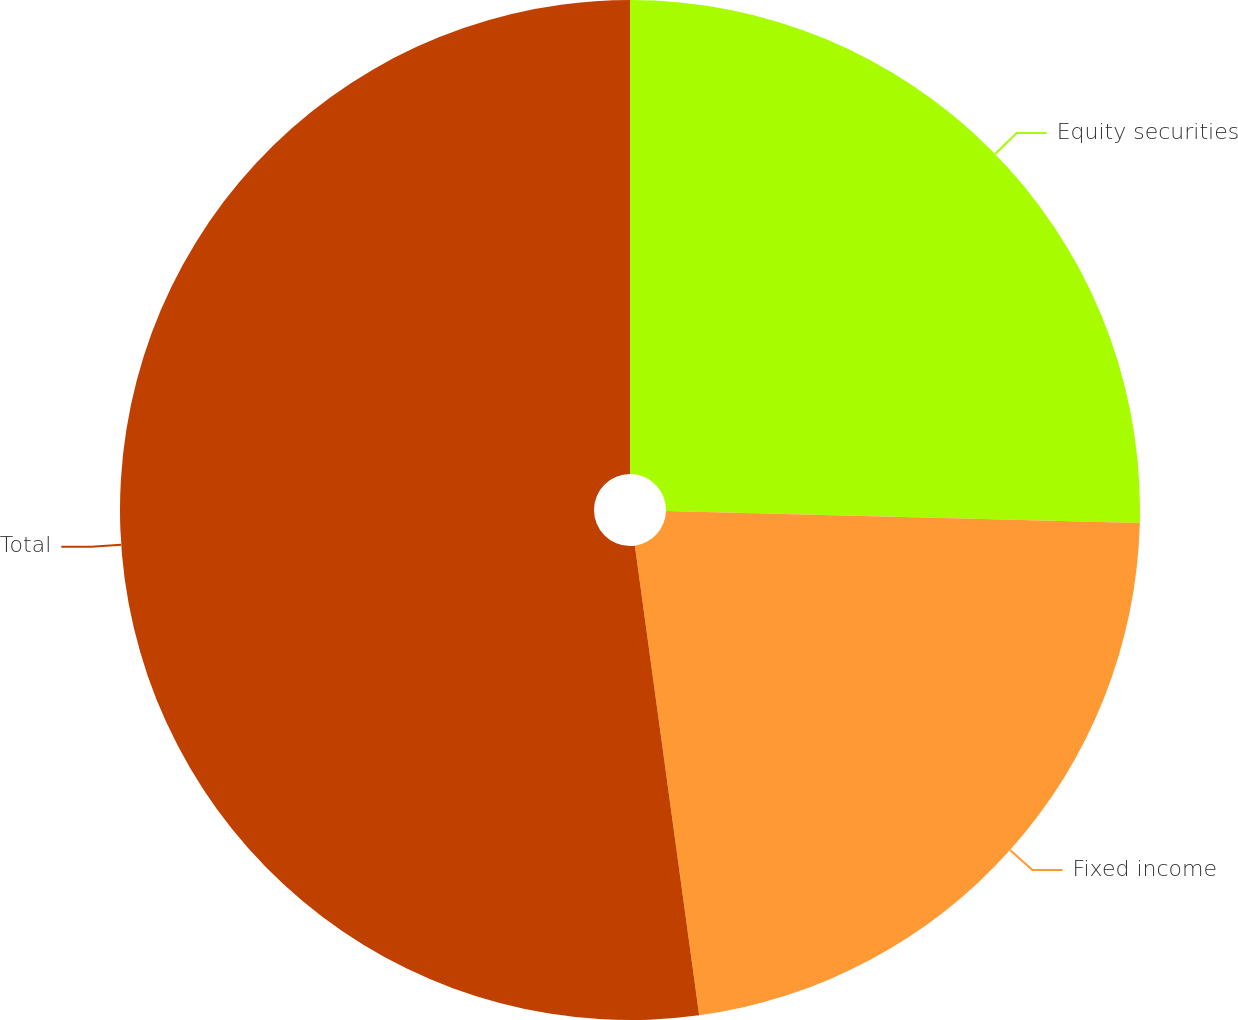Convert chart. <chart><loc_0><loc_0><loc_500><loc_500><pie_chart><fcel>Equity securities<fcel>Fixed income<fcel>Total<nl><fcel>25.4%<fcel>22.43%<fcel>52.16%<nl></chart> 